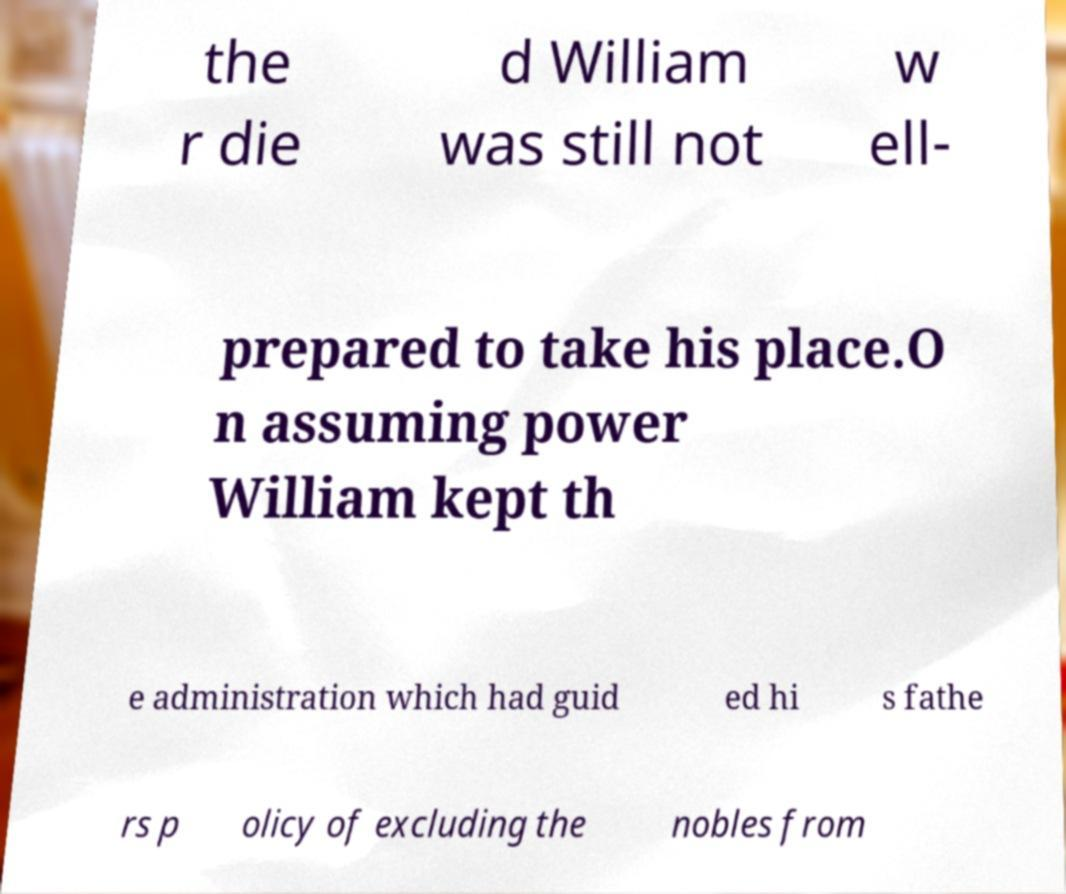There's text embedded in this image that I need extracted. Can you transcribe it verbatim? the r die d William was still not w ell- prepared to take his place.O n assuming power William kept th e administration which had guid ed hi s fathe rs p olicy of excluding the nobles from 